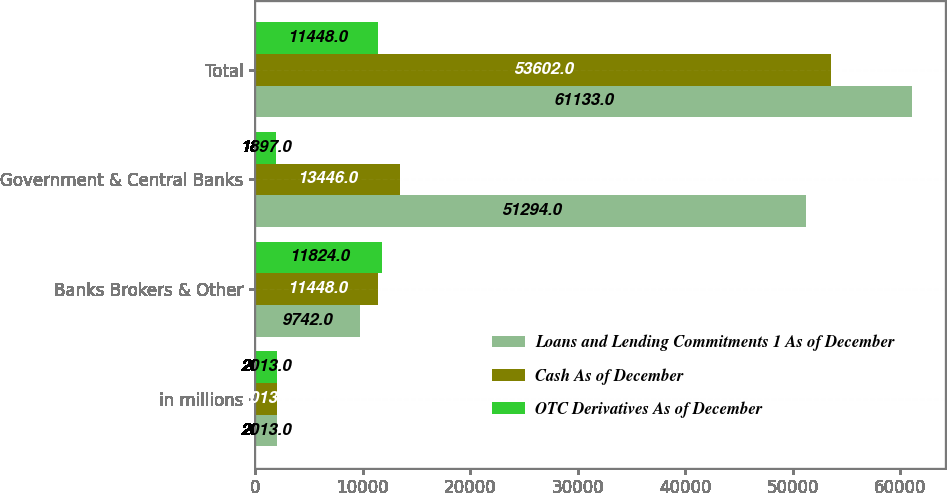Convert chart to OTSL. <chart><loc_0><loc_0><loc_500><loc_500><stacked_bar_chart><ecel><fcel>in millions<fcel>Banks Brokers & Other<fcel>Government & Central Banks<fcel>Total<nl><fcel>Loans and Lending Commitments 1 As of December<fcel>2013<fcel>9742<fcel>51294<fcel>61133<nl><fcel>Cash As of December<fcel>2013<fcel>11448<fcel>13446<fcel>53602<nl><fcel>OTC Derivatives As of December<fcel>2013<fcel>11824<fcel>1897<fcel>11448<nl></chart> 